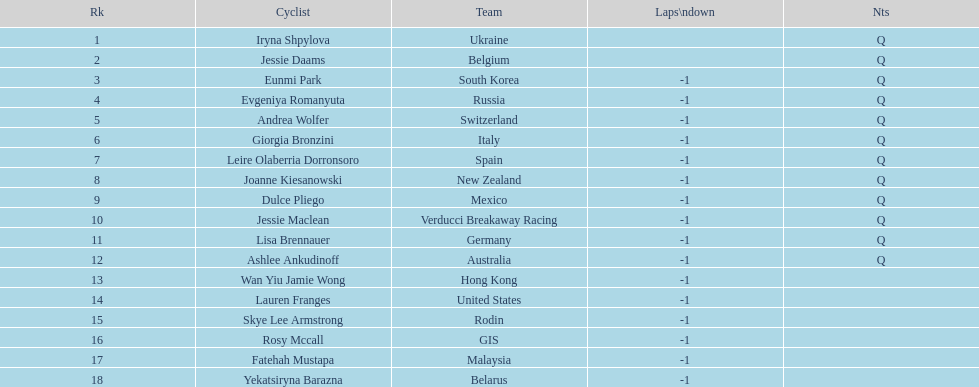What team is listed previous to belgium? Ukraine. 